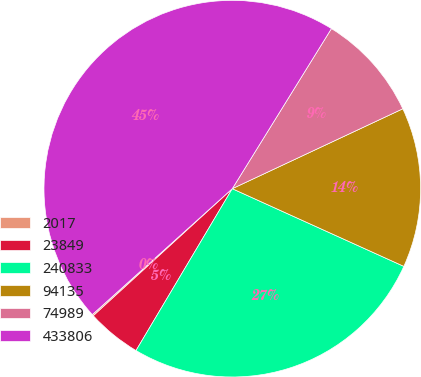<chart> <loc_0><loc_0><loc_500><loc_500><pie_chart><fcel>2017<fcel>23849<fcel>240833<fcel>94135<fcel>74989<fcel>433806<nl><fcel>0.13%<fcel>4.67%<fcel>26.77%<fcel>13.74%<fcel>9.2%<fcel>45.48%<nl></chart> 